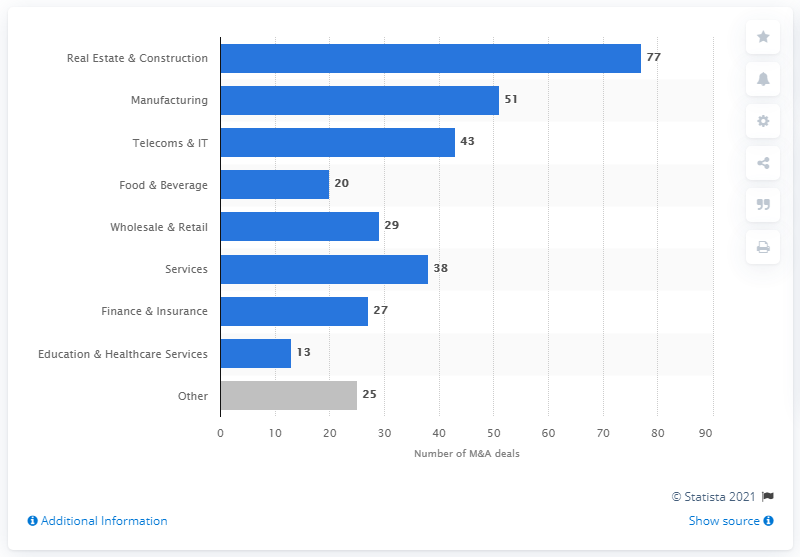How many transactions were completed in Poland in 2018? The bar chart indicates that the number of transactions completed in the Real Estate and Construction sector in Poland in 2018 was 77, which is the highest number of transactions across all the sectors displayed. 